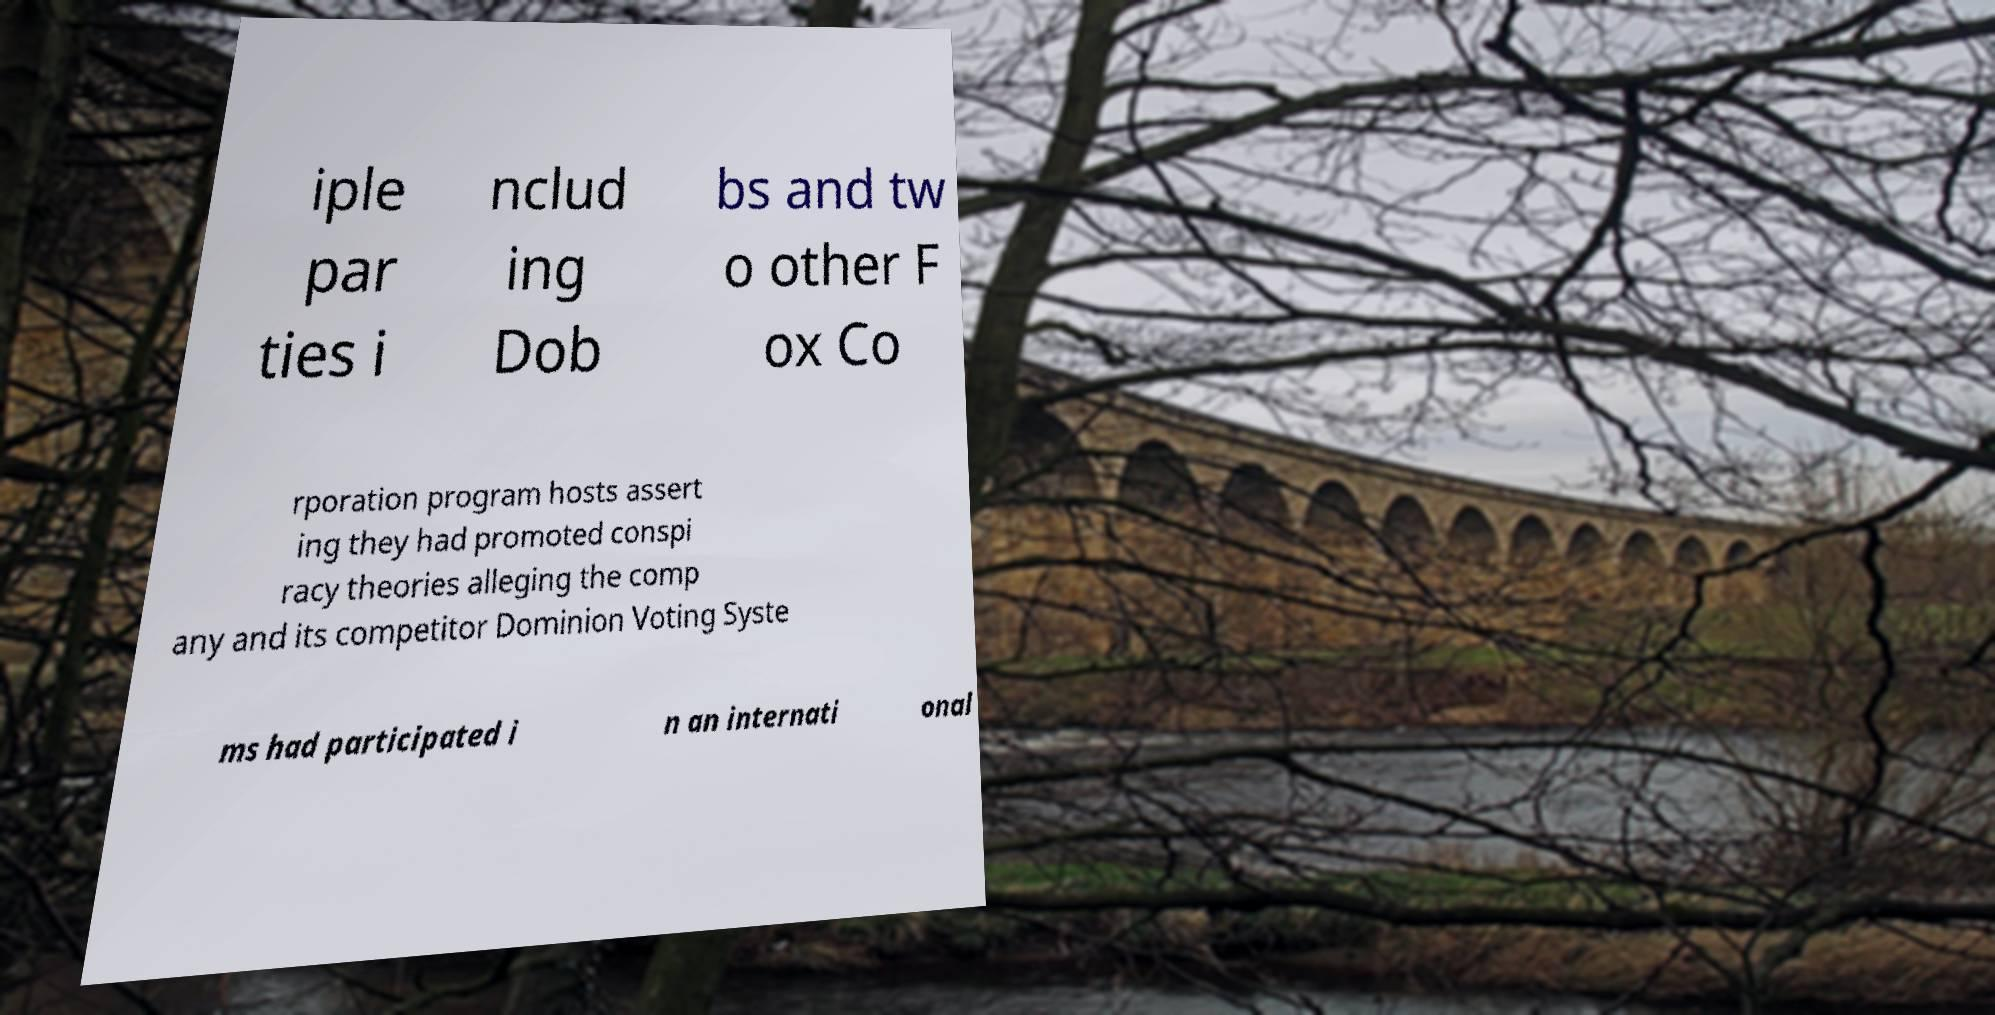Please identify and transcribe the text found in this image. iple par ties i nclud ing Dob bs and tw o other F ox Co rporation program hosts assert ing they had promoted conspi racy theories alleging the comp any and its competitor Dominion Voting Syste ms had participated i n an internati onal 